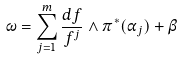Convert formula to latex. <formula><loc_0><loc_0><loc_500><loc_500>{ \omega = \sum _ { j = 1 } ^ { m } \frac { d f } { f ^ { j } } \wedge \pi ^ { * } ( \alpha _ { j } ) + \beta }</formula> 